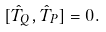<formula> <loc_0><loc_0><loc_500><loc_500>[ \hat { T } _ { Q } , \hat { T } _ { P } ] = 0 .</formula> 